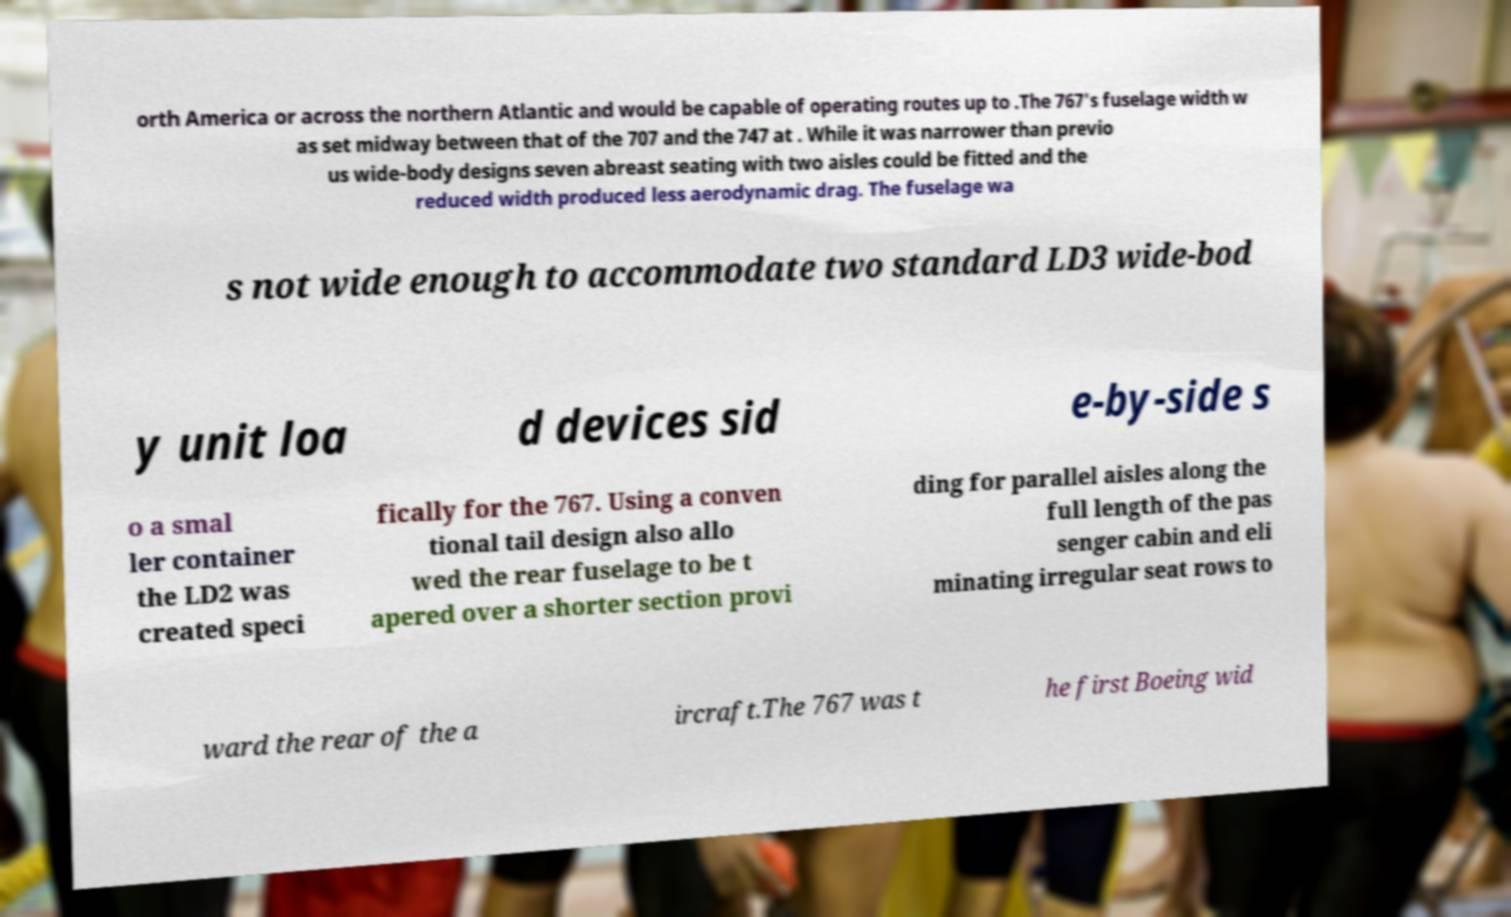For documentation purposes, I need the text within this image transcribed. Could you provide that? orth America or across the northern Atlantic and would be capable of operating routes up to .The 767's fuselage width w as set midway between that of the 707 and the 747 at . While it was narrower than previo us wide-body designs seven abreast seating with two aisles could be fitted and the reduced width produced less aerodynamic drag. The fuselage wa s not wide enough to accommodate two standard LD3 wide-bod y unit loa d devices sid e-by-side s o a smal ler container the LD2 was created speci fically for the 767. Using a conven tional tail design also allo wed the rear fuselage to be t apered over a shorter section provi ding for parallel aisles along the full length of the pas senger cabin and eli minating irregular seat rows to ward the rear of the a ircraft.The 767 was t he first Boeing wid 